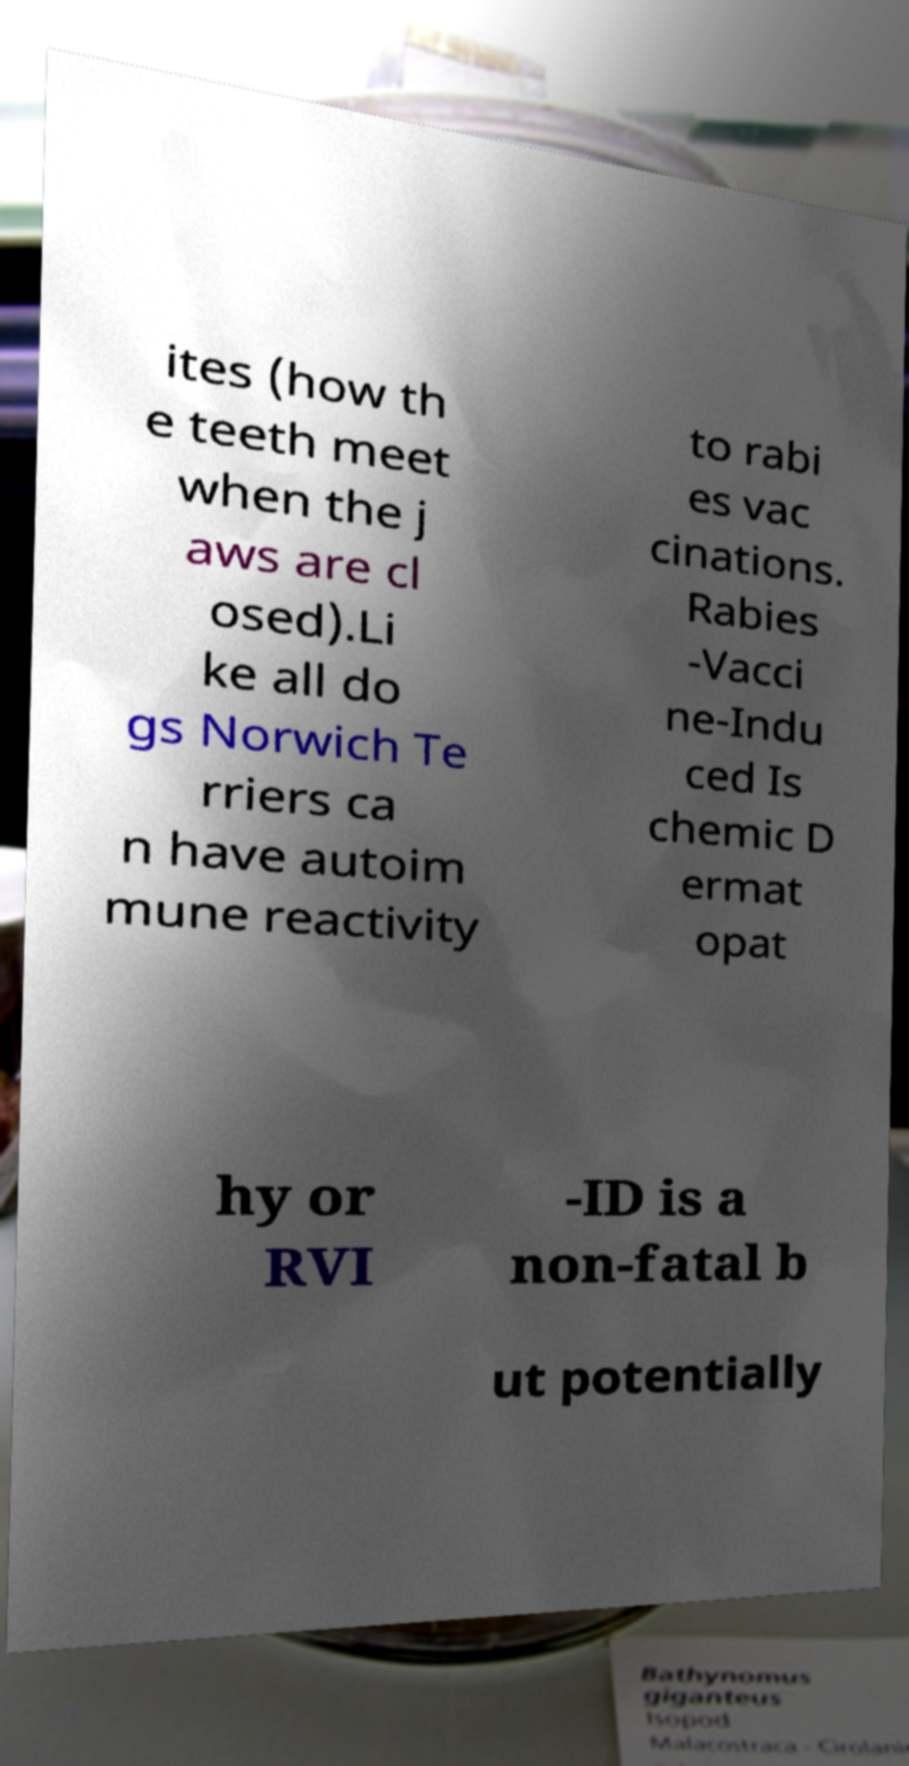For documentation purposes, I need the text within this image transcribed. Could you provide that? ites (how th e teeth meet when the j aws are cl osed).Li ke all do gs Norwich Te rriers ca n have autoim mune reactivity to rabi es vac cinations. Rabies -Vacci ne-Indu ced Is chemic D ermat opat hy or RVI -ID is a non-fatal b ut potentially 